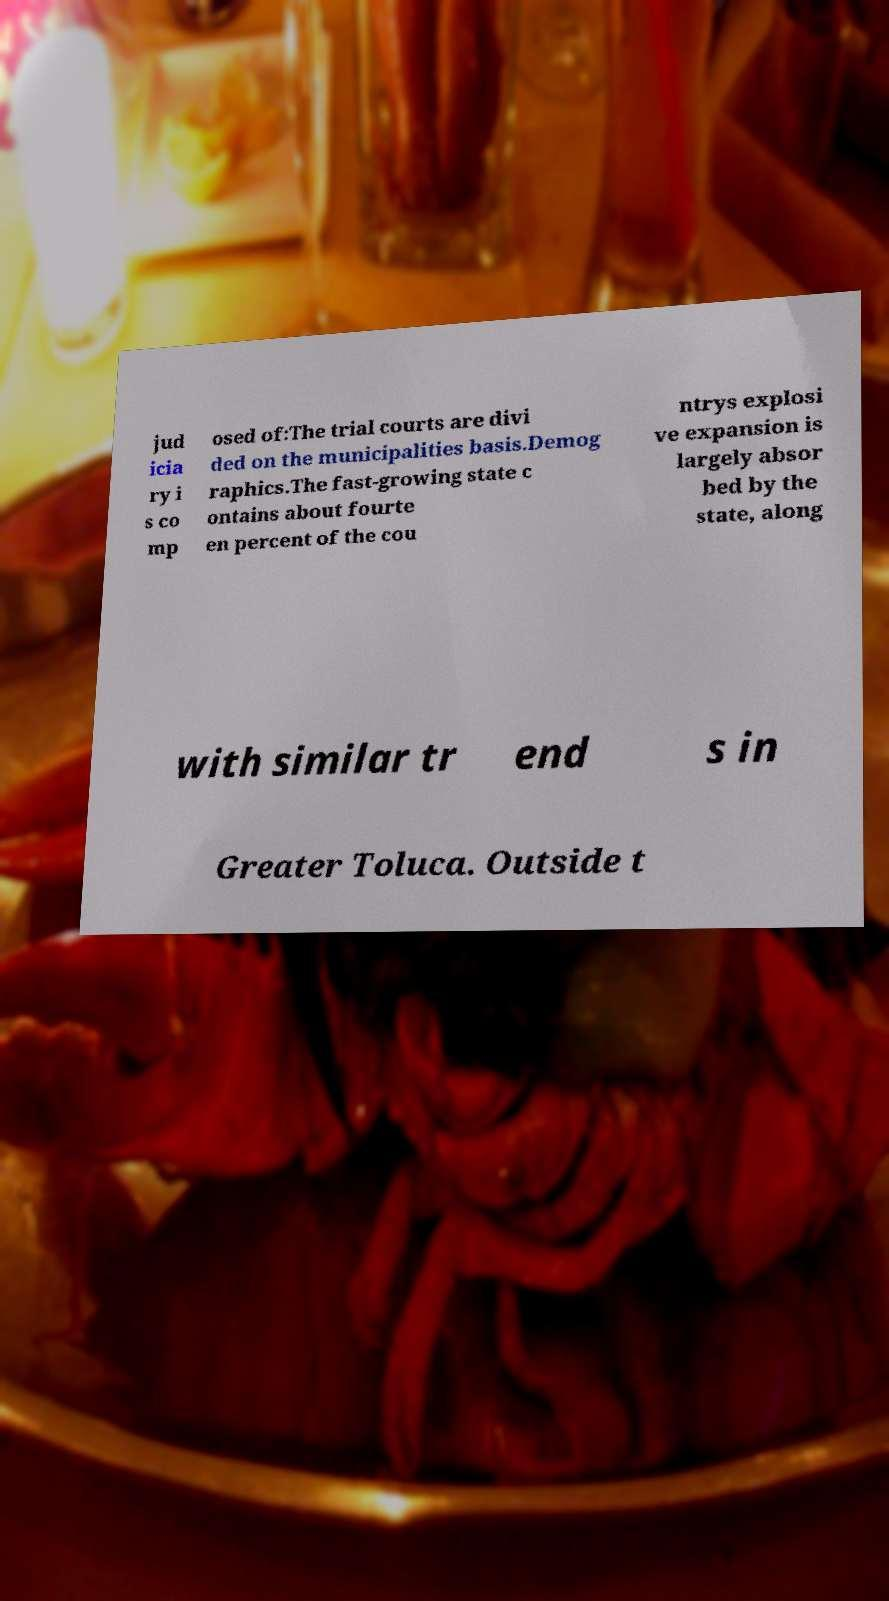For documentation purposes, I need the text within this image transcribed. Could you provide that? jud icia ry i s co mp osed of:The trial courts are divi ded on the municipalities basis.Demog raphics.The fast-growing state c ontains about fourte en percent of the cou ntrys explosi ve expansion is largely absor bed by the state, along with similar tr end s in Greater Toluca. Outside t 